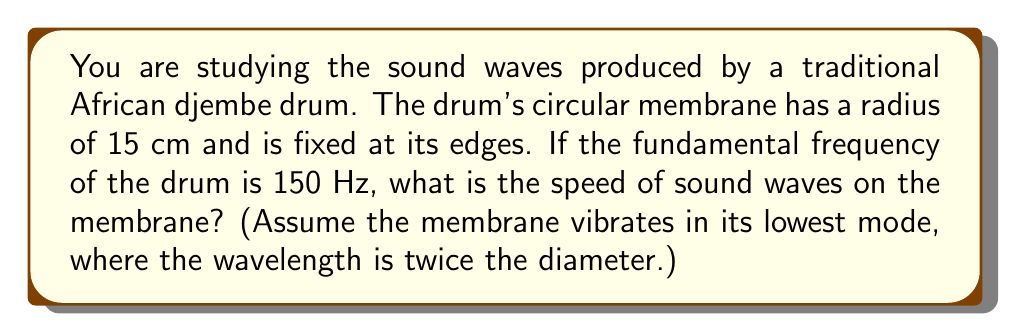Provide a solution to this math problem. Let's approach this step-by-step:

1) First, recall the wave equation for a circular membrane:

   $$f_{mn} = \frac{c}{2\pi R} \alpha_{mn}$$

   where $f_{mn}$ is the frequency, $c$ is the wave speed, $R$ is the radius, and $\alpha_{mn}$ is a constant depending on the mode of vibration.

2) For the fundamental frequency (lowest mode), $m=0$ and $n=1$, and $\alpha_{01} \approx 2.4048$.

3) We're given:
   - Radius $R = 15$ cm $= 0.15$ m
   - Fundamental frequency $f_{01} = 150$ Hz

4) Substituting these into the equation:

   $$150 = \frac{c}{2\pi(0.15)} (2.4048)$$

5) Solve for $c$:

   $$c = \frac{150 \cdot 2\pi \cdot 0.15}{2.4048} \approx 58.9 \text{ m/s}$$

6) We can verify this using the wavelength:
   - Diameter = 30 cm
   - Wavelength $\lambda = 2 \cdot 30$ cm $= 60$ cm $= 0.6$ m
   - Using $c = f\lambda$:
     $$c = 150 \text{ Hz} \cdot 0.6 \text{ m} = 90 \text{ m/s}$$

   This is close to our calculated value, considering the approximation in step 2.
Answer: $58.9 \text{ m/s}$ 